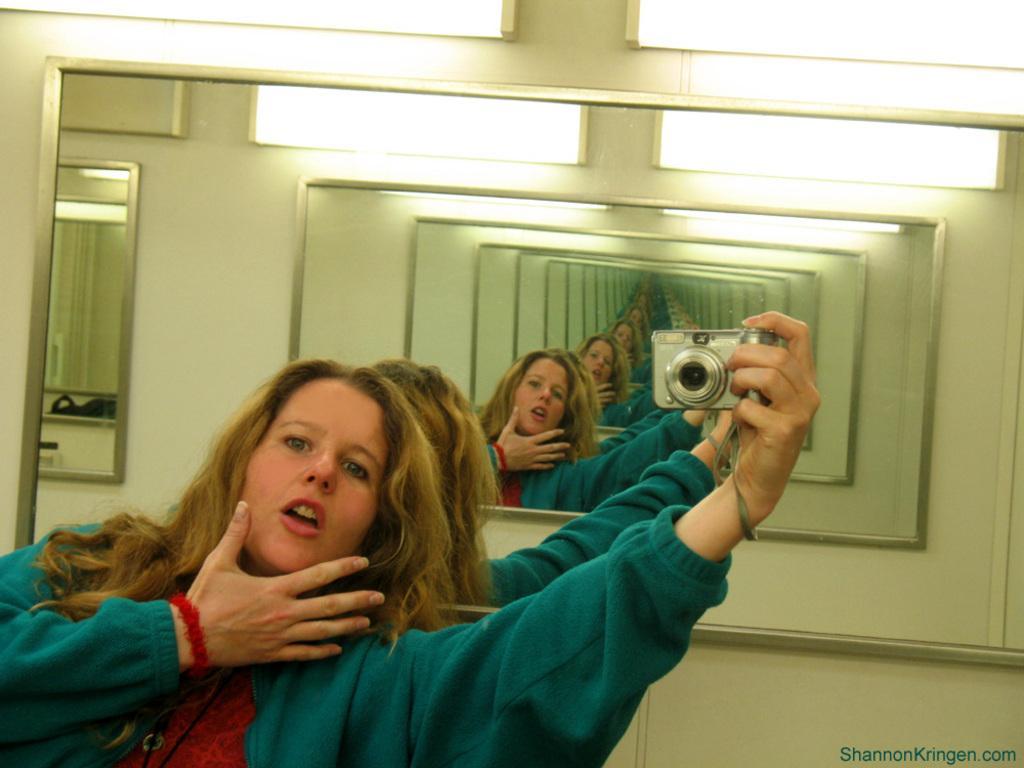How would you summarize this image in a sentence or two? In this picture there is a woman towards the left, she is wearing a green jacket and red top and she is holding a camera. Behind her there is a mirror. In the mirror, there are reflections of women and camera. 